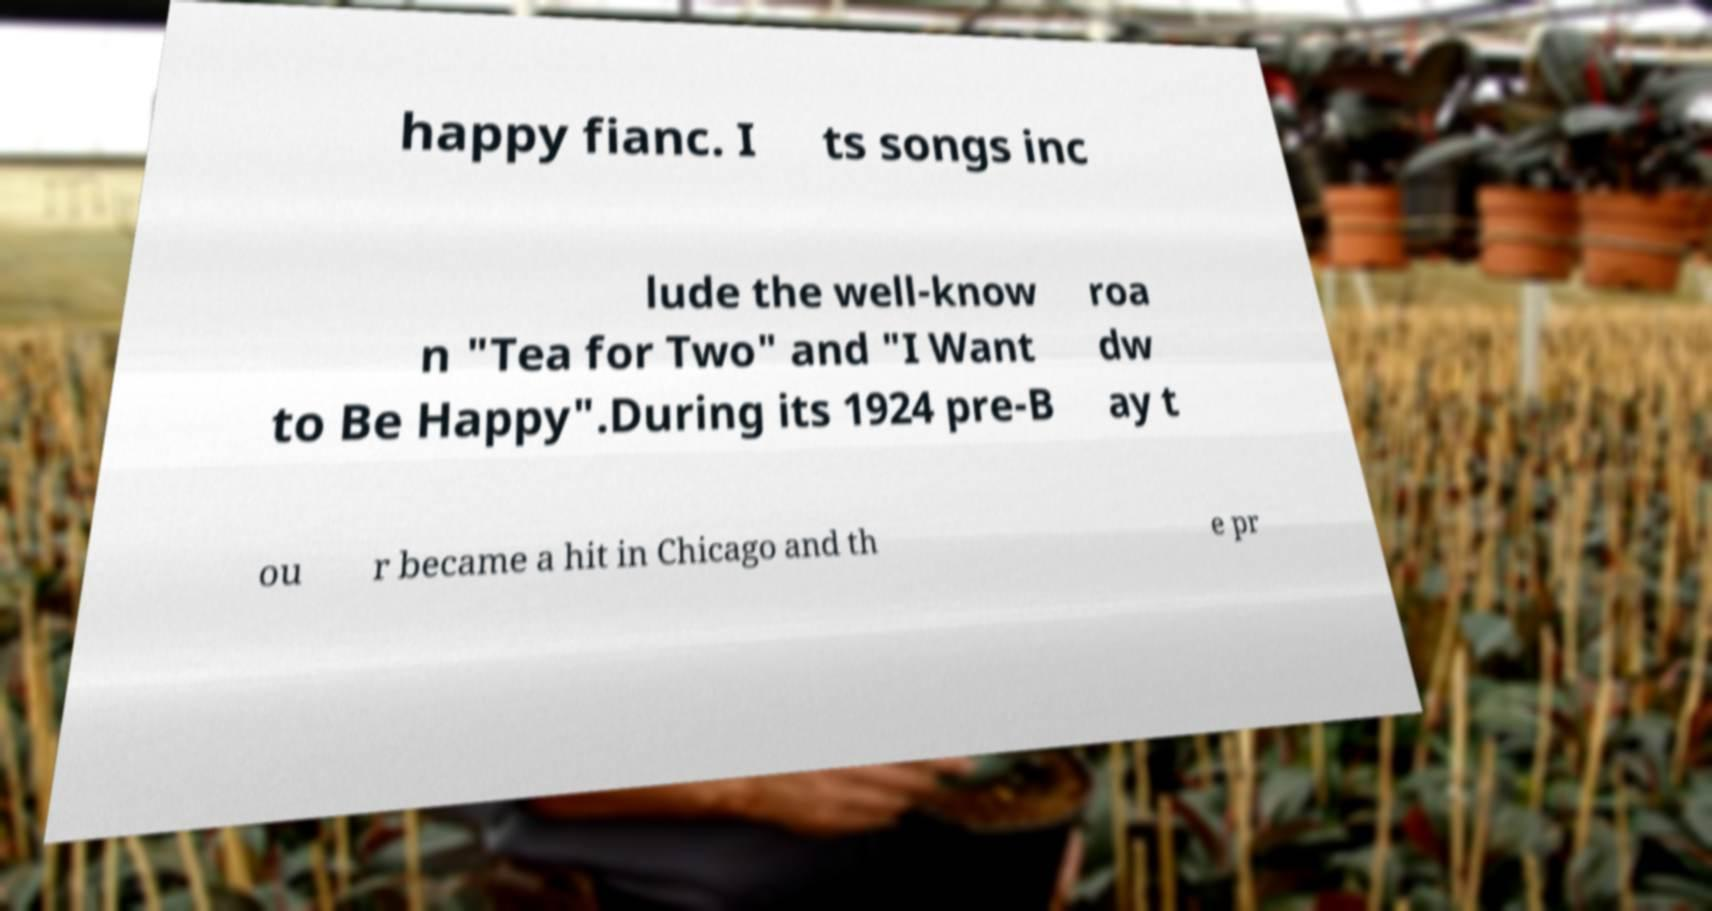Please identify and transcribe the text found in this image. happy fianc. I ts songs inc lude the well-know n "Tea for Two" and "I Want to Be Happy".During its 1924 pre-B roa dw ay t ou r became a hit in Chicago and th e pr 